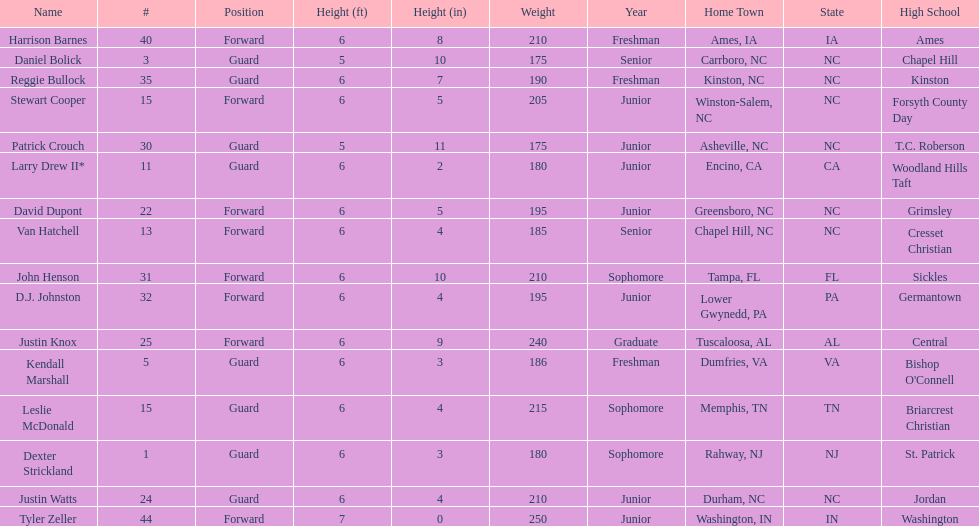Would you be able to parse every entry in this table? {'header': ['Name', '#', 'Position', 'Height (ft)', 'Height (in)', 'Weight', 'Year', 'Home Town', 'State', 'High School'], 'rows': [['Harrison Barnes', '40', 'Forward', '6', '8', '210', 'Freshman', 'Ames, IA', 'IA', 'Ames'], ['Daniel Bolick', '3', 'Guard', '5', '10', '175', 'Senior', 'Carrboro, NC', 'NC', 'Chapel Hill'], ['Reggie Bullock', '35', 'Guard', '6', '7', '190', 'Freshman', 'Kinston, NC', 'NC', 'Kinston'], ['Stewart Cooper', '15', 'Forward', '6', '5', '205', 'Junior', 'Winston-Salem, NC', 'NC', 'Forsyth County Day'], ['Patrick Crouch', '30', 'Guard', '5', '11', '175', 'Junior', 'Asheville, NC', 'NC', 'T.C. Roberson'], ['Larry Drew II*', '11', 'Guard', '6', '2', '180', 'Junior', 'Encino, CA', 'CA', 'Woodland Hills Taft'], ['David Dupont', '22', 'Forward', '6', '5', '195', 'Junior', 'Greensboro, NC', 'NC', 'Grimsley'], ['Van Hatchell', '13', 'Forward', '6', '4', '185', 'Senior', 'Chapel Hill, NC', 'NC', 'Cresset Christian'], ['John Henson', '31', 'Forward', '6', '10', '210', 'Sophomore', 'Tampa, FL', 'FL', 'Sickles'], ['D.J. Johnston', '32', 'Forward', '6', '4', '195', 'Junior', 'Lower Gwynedd, PA', 'PA', 'Germantown'], ['Justin Knox', '25', 'Forward', '6', '9', '240', 'Graduate', 'Tuscaloosa, AL', 'AL', 'Central'], ['Kendall Marshall', '5', 'Guard', '6', '3', '186', 'Freshman', 'Dumfries, VA', 'VA', "Bishop O'Connell"], ['Leslie McDonald', '15', 'Guard', '6', '4', '215', 'Sophomore', 'Memphis, TN', 'TN', 'Briarcrest Christian'], ['Dexter Strickland', '1', 'Guard', '6', '3', '180', 'Sophomore', 'Rahway, NJ', 'NJ', 'St. Patrick'], ['Justin Watts', '24', 'Guard', '6', '4', '210', 'Junior', 'Durham, NC', 'NC', 'Jordan'], ['Tyler Zeller', '44', 'Forward', '7', '0', '250', 'Junior', 'Washington, IN', 'IN', 'Washington']]} Who was taller, justin knox or john henson? John Henson. 